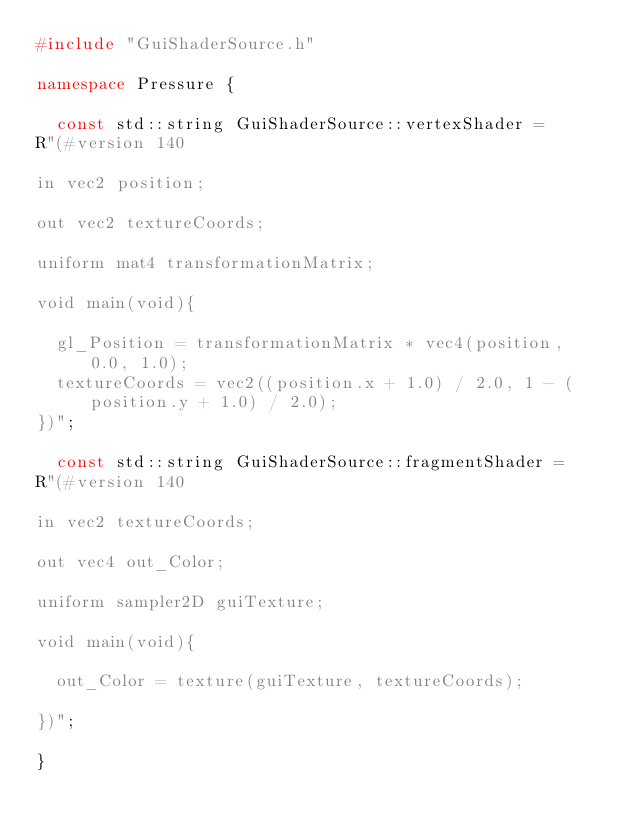<code> <loc_0><loc_0><loc_500><loc_500><_C++_>#include "GuiShaderSource.h"

namespace Pressure {
	
	const std::string GuiShaderSource::vertexShader = 
R"(#version 140

in vec2 position;

out vec2 textureCoords;

uniform mat4 transformationMatrix;

void main(void){

	gl_Position = transformationMatrix * vec4(position, 0.0, 1.0);
	textureCoords = vec2((position.x + 1.0) / 2.0, 1 - (position.y + 1.0) / 2.0);
})";

	const std::string GuiShaderSource::fragmentShader = 
R"(#version 140

in vec2 textureCoords;

out vec4 out_Color;

uniform sampler2D guiTexture;

void main(void){

	out_Color = texture(guiTexture, textureCoords);

})";

}</code> 